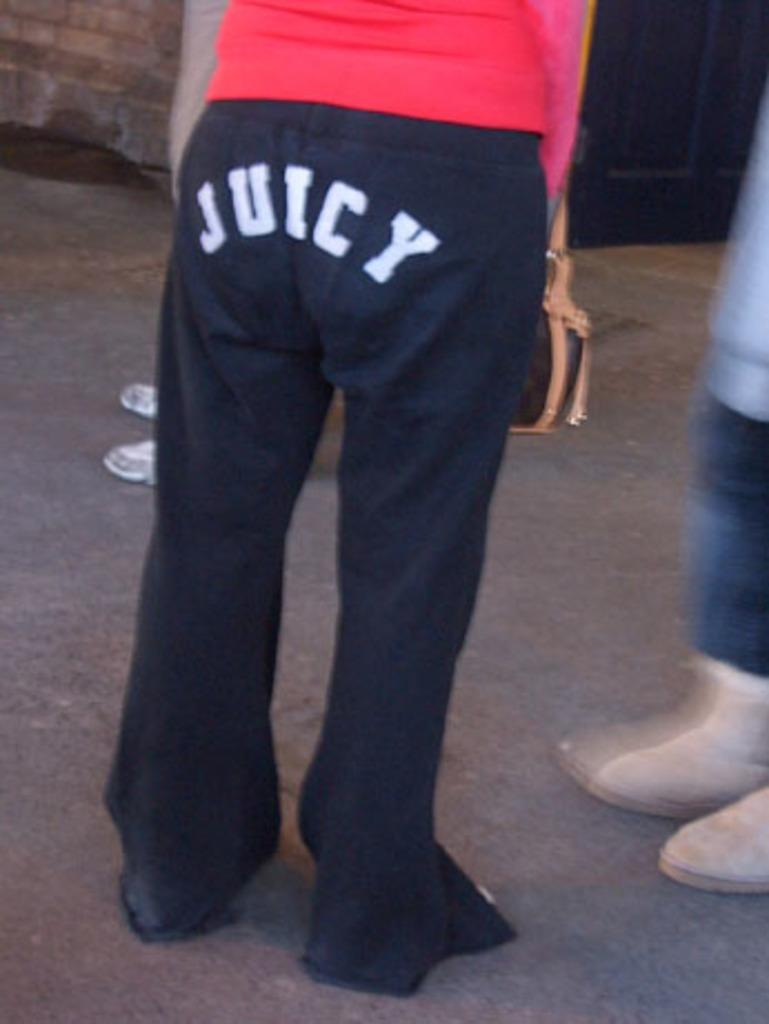Provide a one-sentence caption for the provided image. Person is wearing some juicy pants standing in a line. 